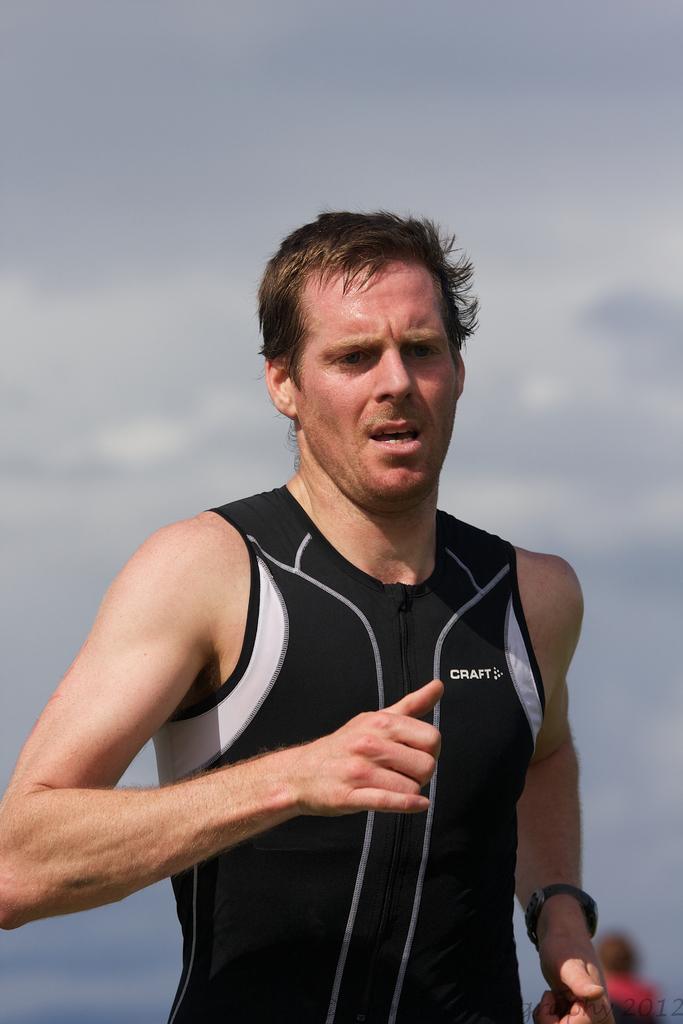What is the brand of shirt the runner is wearing?
Provide a short and direct response. Craft. 